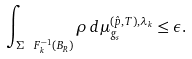Convert formula to latex. <formula><loc_0><loc_0><loc_500><loc_500>\int _ { \Sigma \ F ^ { - 1 } _ { k } ( B _ { R } ) } \rho \, d \mu _ { g _ { s } } ^ { ( \hat { p } , T ) , \lambda _ { k } } \leq \epsilon .</formula> 